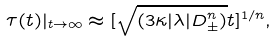<formula> <loc_0><loc_0><loc_500><loc_500>\tau ( t ) | _ { t \to \infty } \approx [ \sqrt { ( 3 \kappa | \lambda | D _ { \pm } ^ { n } ) } t ] ^ { 1 / n } ,</formula> 